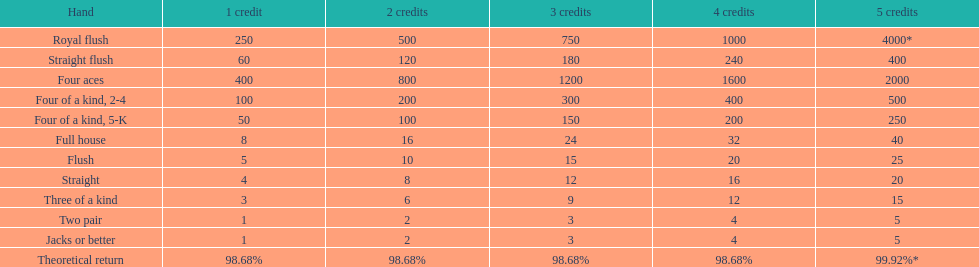For a one credit stake on a royal flush, what is the number of credits earned? 250. 